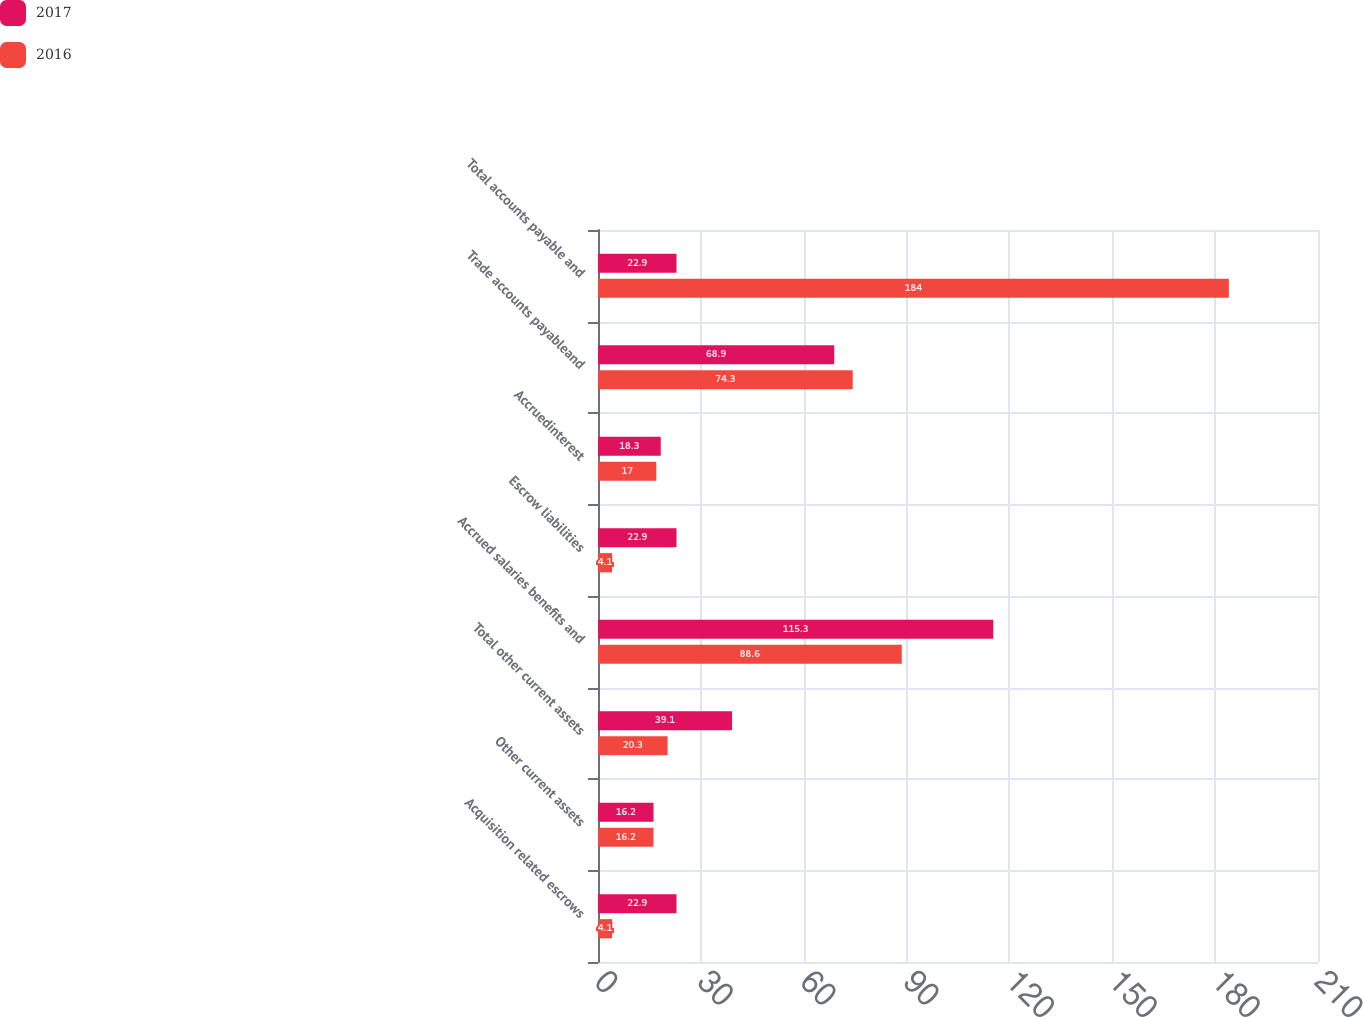<chart> <loc_0><loc_0><loc_500><loc_500><stacked_bar_chart><ecel><fcel>Acquisition related escrows<fcel>Other current assets<fcel>Total other current assets<fcel>Accrued salaries benefits and<fcel>Escrow liabilities<fcel>Accruedinterest<fcel>Trade accounts payableand<fcel>Total accounts payable and<nl><fcel>2017<fcel>22.9<fcel>16.2<fcel>39.1<fcel>115.3<fcel>22.9<fcel>18.3<fcel>68.9<fcel>22.9<nl><fcel>2016<fcel>4.1<fcel>16.2<fcel>20.3<fcel>88.6<fcel>4.1<fcel>17<fcel>74.3<fcel>184<nl></chart> 